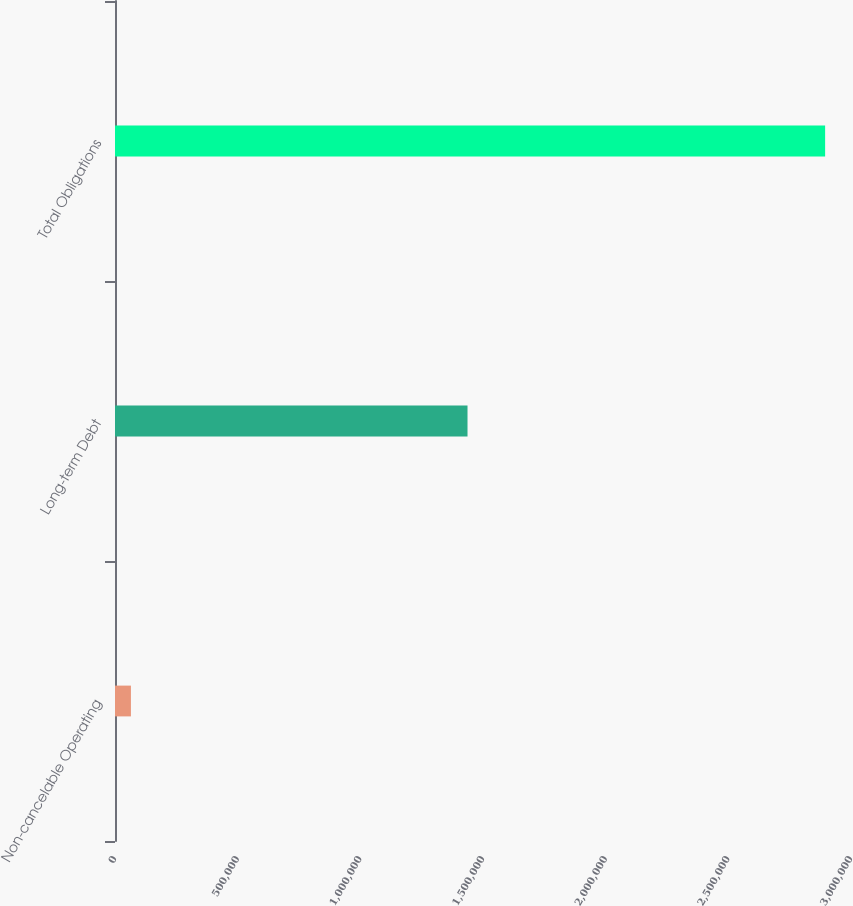Convert chart to OTSL. <chart><loc_0><loc_0><loc_500><loc_500><bar_chart><fcel>Non-cancelable Operating<fcel>Long-term Debt<fcel>Total Obligations<nl><fcel>64921<fcel>1.43689e+06<fcel>2.89451e+06<nl></chart> 